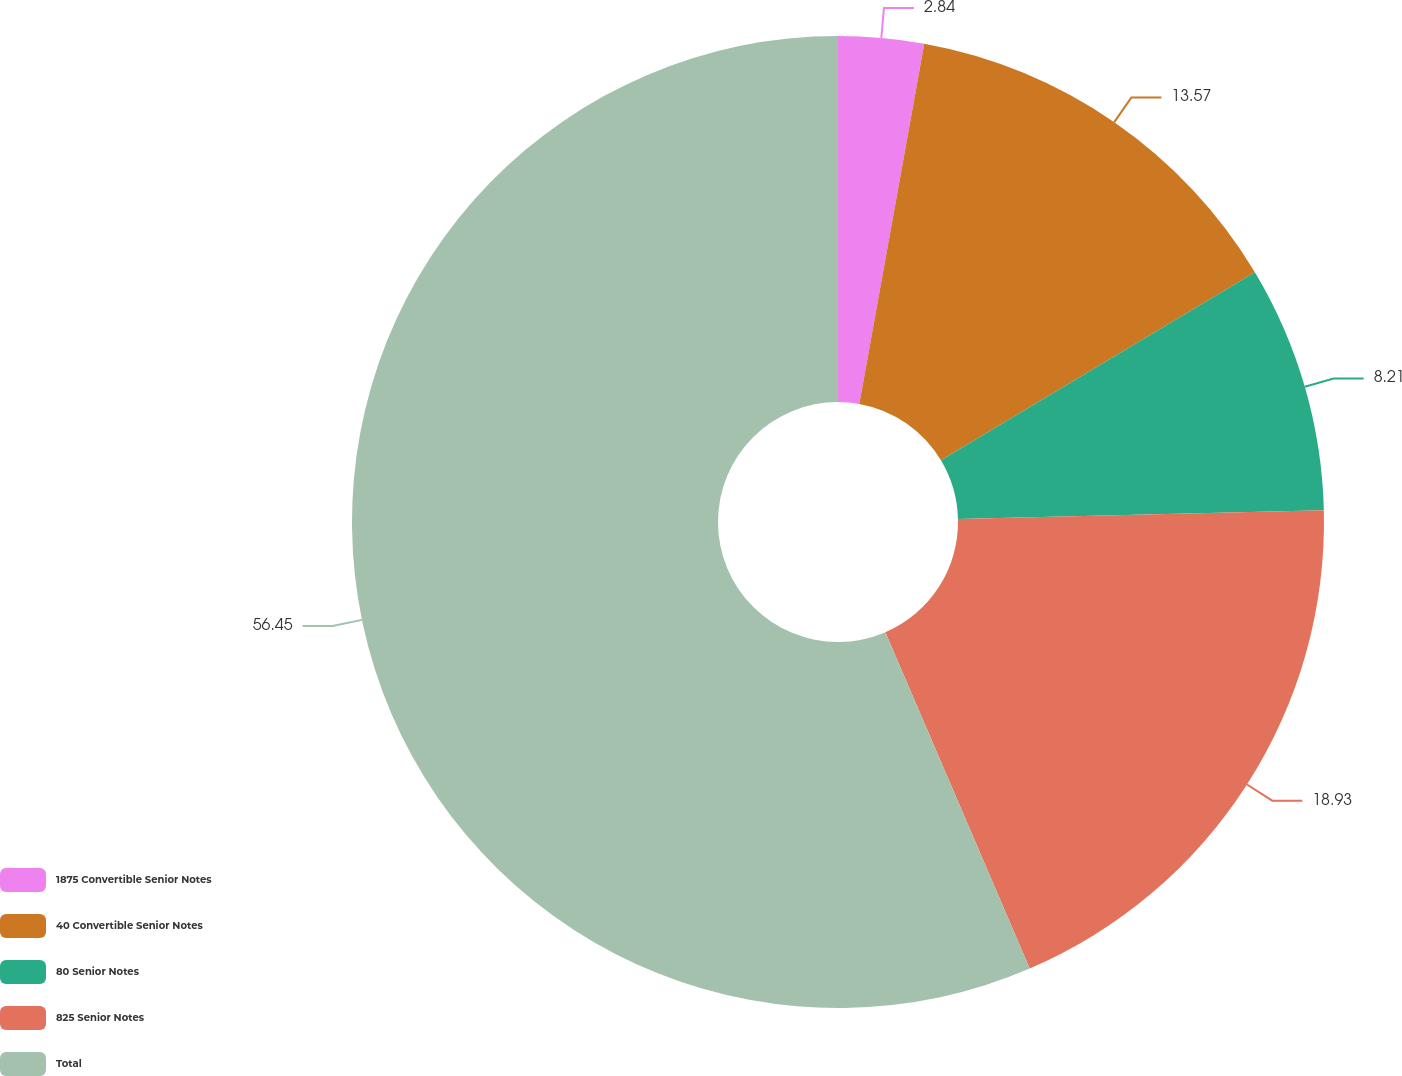Convert chart. <chart><loc_0><loc_0><loc_500><loc_500><pie_chart><fcel>1875 Convertible Senior Notes<fcel>40 Convertible Senior Notes<fcel>80 Senior Notes<fcel>825 Senior Notes<fcel>Total<nl><fcel>2.84%<fcel>13.57%<fcel>8.21%<fcel>18.93%<fcel>56.46%<nl></chart> 